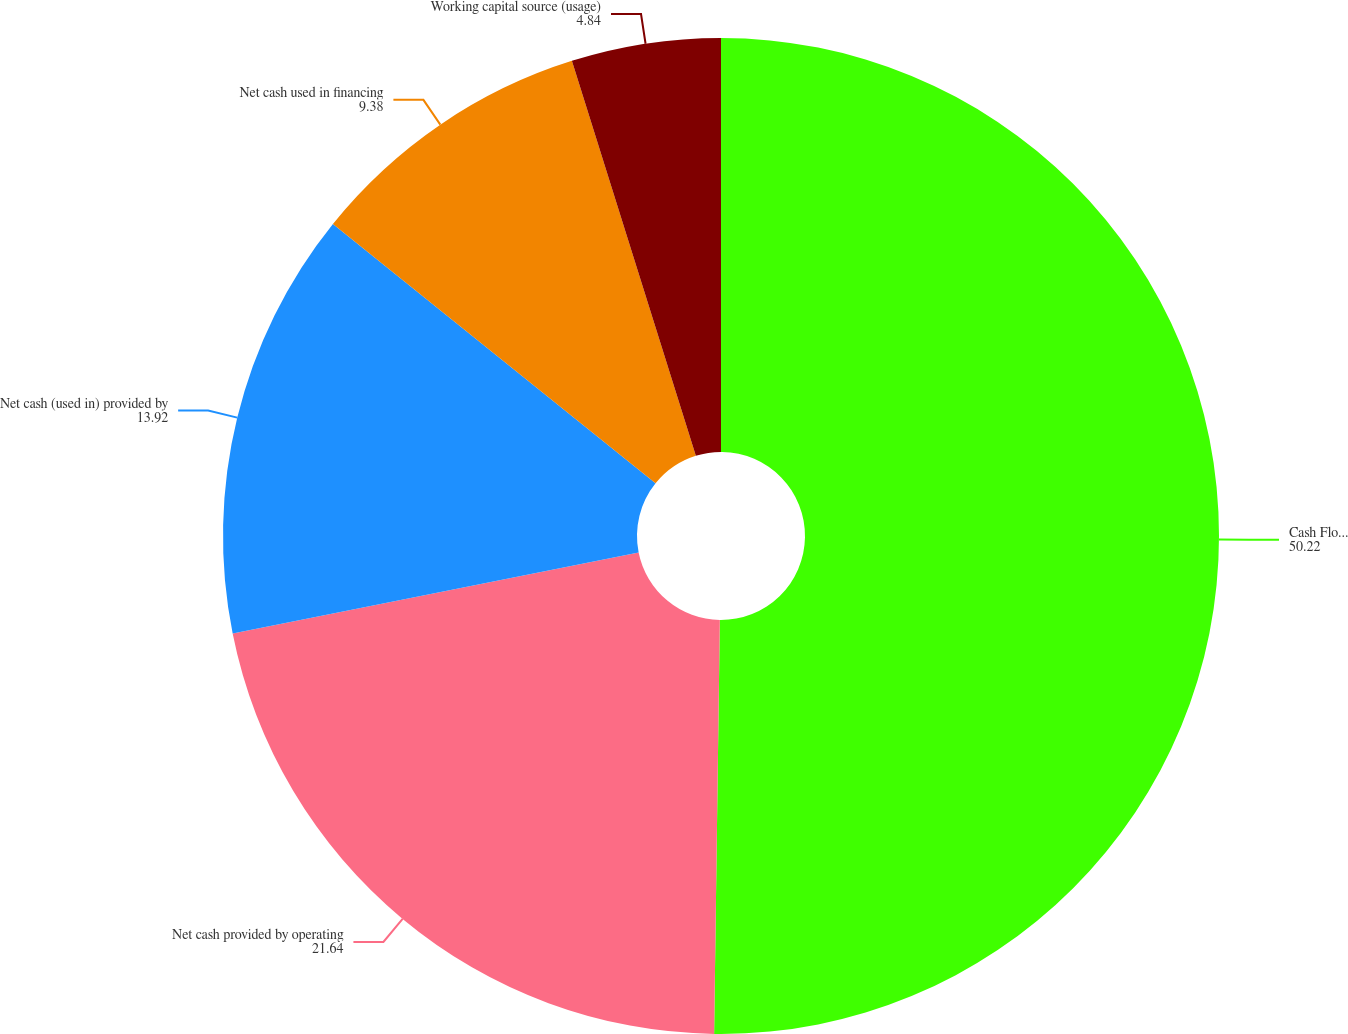<chart> <loc_0><loc_0><loc_500><loc_500><pie_chart><fcel>Cash Flow Data<fcel>Net cash provided by operating<fcel>Net cash (used in) provided by<fcel>Net cash used in financing<fcel>Working capital source (usage)<nl><fcel>50.22%<fcel>21.64%<fcel>13.92%<fcel>9.38%<fcel>4.84%<nl></chart> 